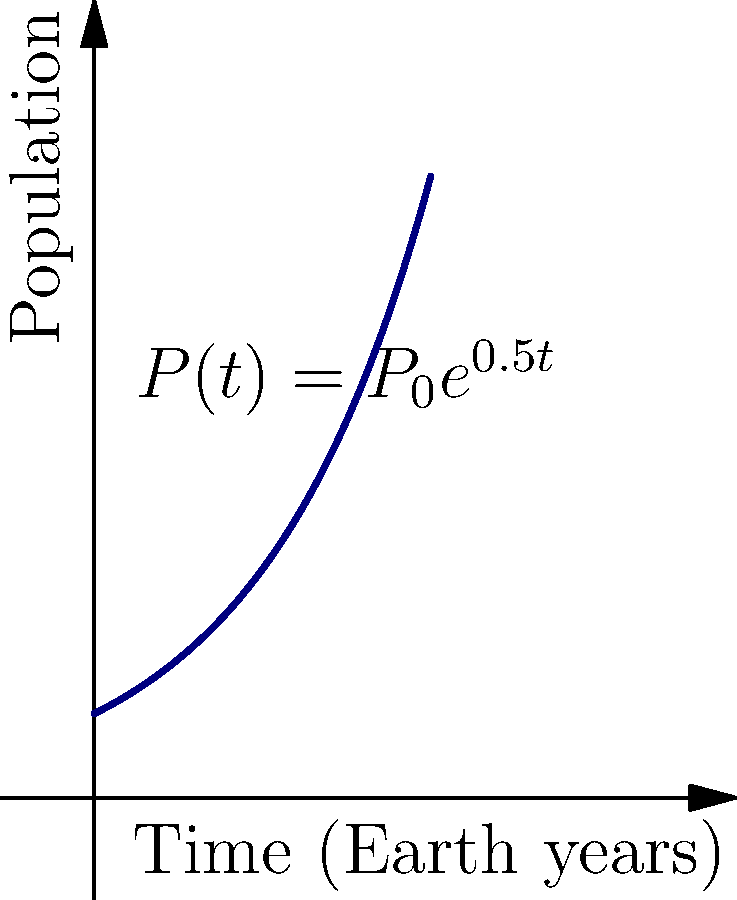On a newly discovered exoplanet, an alien species' population growth follows the exponential model $P(t) = P_0e^{0.5t}$, where $P_0$ is the initial population and $t$ is time in Earth years. At what rate is the population changing after 2 Earth years? To find the rate of change of the population after 2 Earth years, we need to follow these steps:

1) The population function is given by $P(t) = P_0e^{0.5t}$

2) To find the rate of change, we need to differentiate this function with respect to t:
   
   $\frac{dP}{dt} = P_0 \cdot 0.5e^{0.5t}$

3) Simplify:
   
   $\frac{dP}{dt} = 0.5P_0e^{0.5t}$

4) Notice that this is equal to $0.5P(t)$

5) After 2 Earth years, $t = 2$, so the population at this time is:
   
   $P(2) = P_0e^{0.5(2)} = P_0e^1$

6) Therefore, the rate of change at $t = 2$ is:
   
   $\frac{dP}{dt}|_{t=2} = 0.5P(2) = 0.5P_0e^1$

This means the population is growing at a rate of $0.5P_0e^1$ aliens per Earth year when $t = 2$.
Answer: $0.5P_0e^1$ aliens per Earth year 